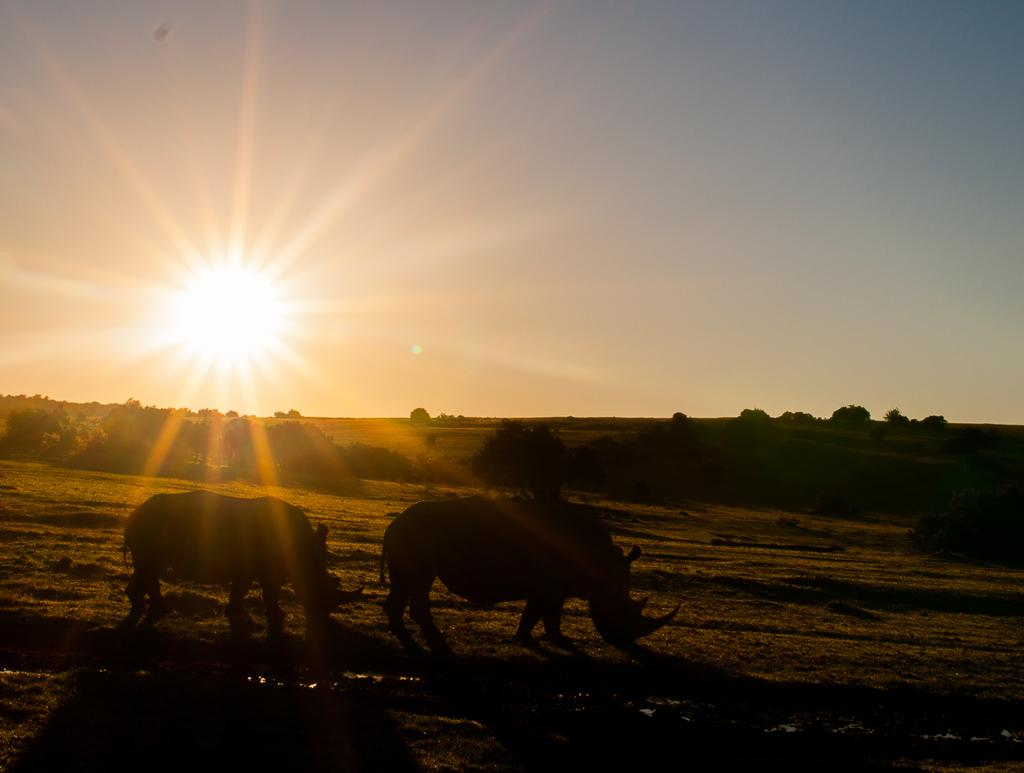What type of living organisms can be seen on the ground in the image? There are animals on the ground in the image. What can be seen in the background of the image? There are trees and the sky visible in the background of the image. What type of string is being used by the carpenter in the image? There is no carpenter or string present in the image. Is the veil being used by any of the animals in the image? There is no veil present in the image, and no animals are using any such item. 